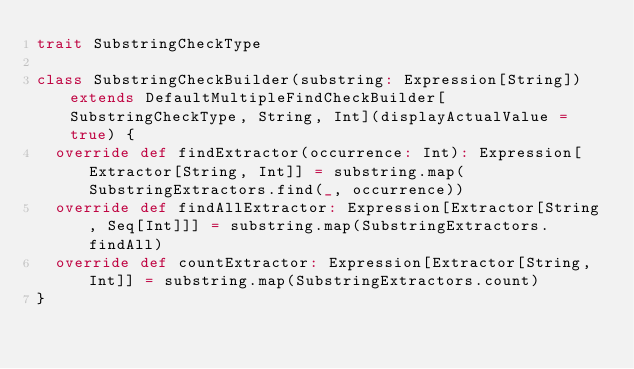Convert code to text. <code><loc_0><loc_0><loc_500><loc_500><_Scala_>trait SubstringCheckType

class SubstringCheckBuilder(substring: Expression[String]) extends DefaultMultipleFindCheckBuilder[SubstringCheckType, String, Int](displayActualValue = true) {
  override def findExtractor(occurrence: Int): Expression[Extractor[String, Int]] = substring.map(SubstringExtractors.find(_, occurrence))
  override def findAllExtractor: Expression[Extractor[String, Seq[Int]]] = substring.map(SubstringExtractors.findAll)
  override def countExtractor: Expression[Extractor[String, Int]] = substring.map(SubstringExtractors.count)
}
</code> 